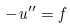<formula> <loc_0><loc_0><loc_500><loc_500>- u ^ { \prime \prime } = f</formula> 